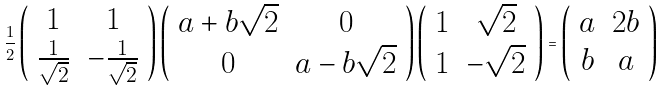<formula> <loc_0><loc_0><loc_500><loc_500>\frac { 1 } { 2 } \left ( \begin{array} { c c } 1 & 1 \\ \frac { 1 } { \sqrt { 2 } } & - \frac { 1 } { \sqrt { 2 } } \end{array} \right ) \left ( \begin{array} { c c } a + b \sqrt { 2 } & 0 \\ 0 & a - b \sqrt { 2 } \end{array} \right ) \left ( \begin{array} { c c } 1 & \sqrt { 2 } \\ 1 & - \sqrt { 2 } \end{array} \right ) = \left ( \begin{array} { c c } a & 2 b \\ b & a \end{array} \right )</formula> 